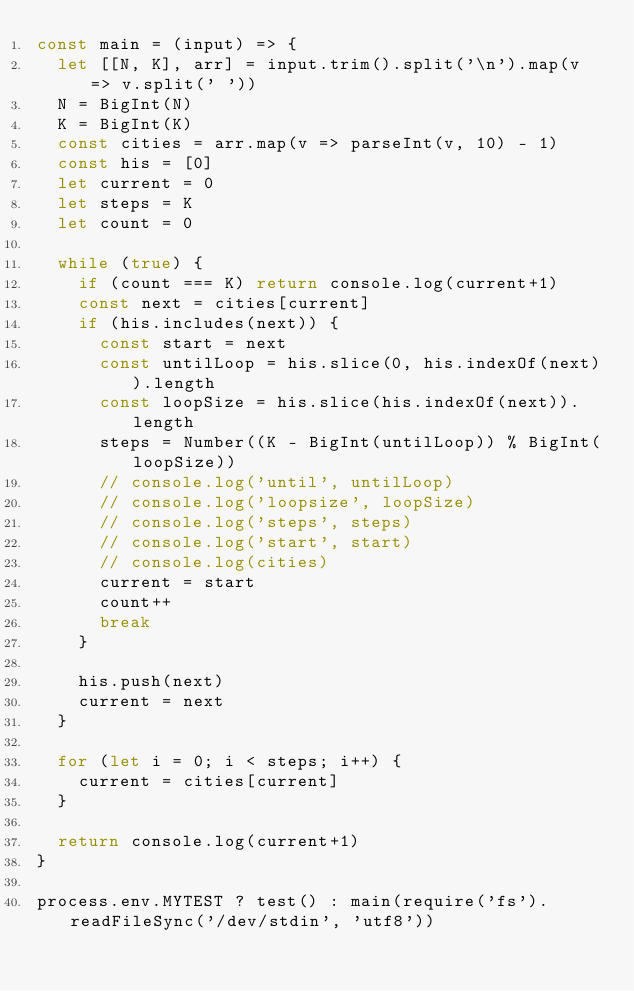Convert code to text. <code><loc_0><loc_0><loc_500><loc_500><_JavaScript_>const main = (input) => {
  let [[N, K], arr] = input.trim().split('\n').map(v => v.split(' '))
  N = BigInt(N)
  K = BigInt(K)
  const cities = arr.map(v => parseInt(v, 10) - 1)
  const his = [0]
  let current = 0
  let steps = K
  let count = 0
  
  while (true) {
    if (count === K) return console.log(current+1)
    const next = cities[current]
    if (his.includes(next)) {
      const start = next
      const untilLoop = his.slice(0, his.indexOf(next)).length
      const loopSize = his.slice(his.indexOf(next)).length
      steps = Number((K - BigInt(untilLoop)) % BigInt(loopSize))
      // console.log('until', untilLoop)
      // console.log('loopsize', loopSize)
      // console.log('steps', steps)
      // console.log('start', start)
      // console.log(cities)
      current = start
      count++
      break
    }

    his.push(next)
    current = next
  }

  for (let i = 0; i < steps; i++) {
    current = cities[current]
  }

  return console.log(current+1)
}

process.env.MYTEST ? test() : main(require('fs').readFileSync('/dev/stdin', 'utf8'))</code> 